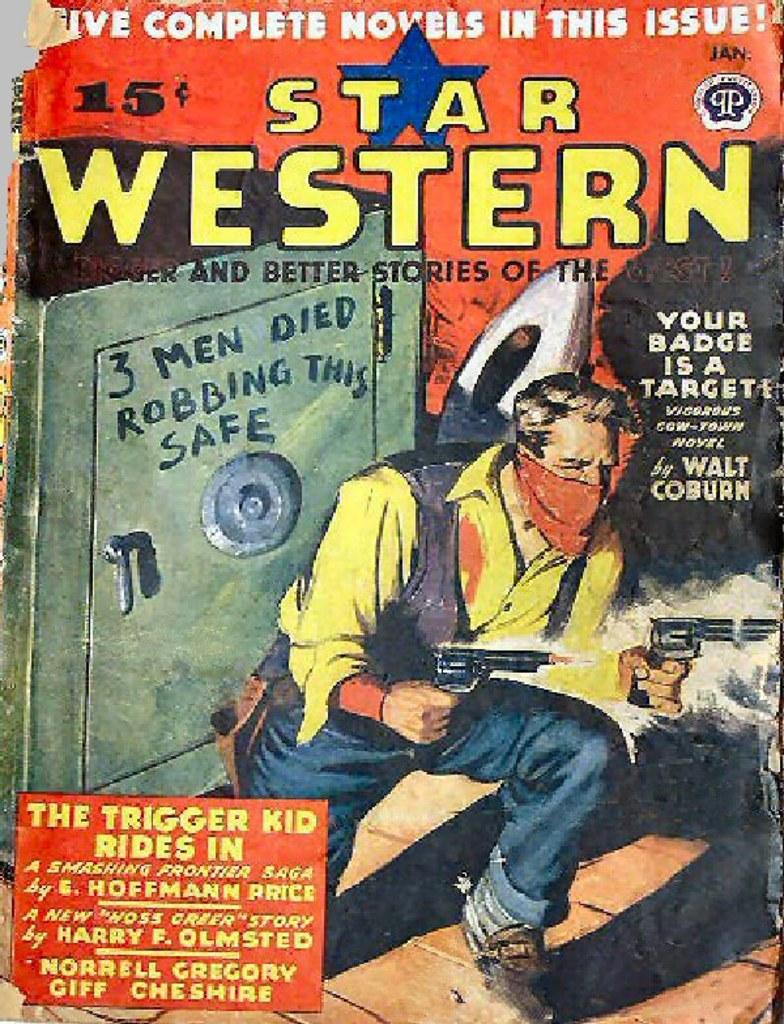What is the name of the comic?
Ensure brevity in your answer.  Star western. How much did this comic cost?
Your response must be concise. 15 cents. 